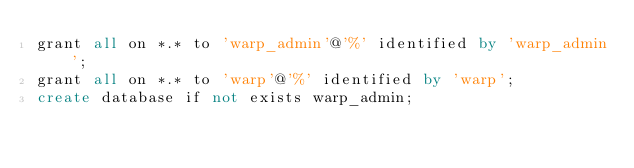Convert code to text. <code><loc_0><loc_0><loc_500><loc_500><_SQL_>grant all on *.* to 'warp_admin'@'%' identified by 'warp_admin';
grant all on *.* to 'warp'@'%' identified by 'warp';
create database if not exists warp_admin;
</code> 